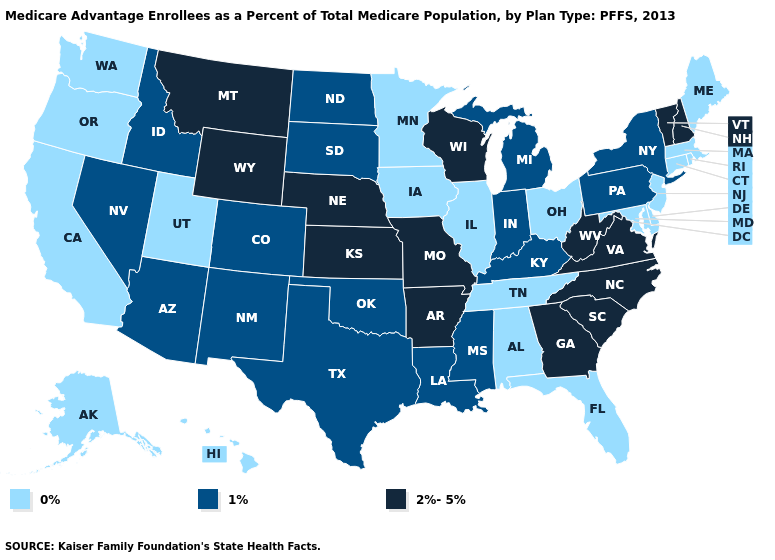Does California have the lowest value in the USA?
Concise answer only. Yes. Does the first symbol in the legend represent the smallest category?
Short answer required. Yes. Name the states that have a value in the range 2%-5%?
Write a very short answer. Arkansas, Georgia, Kansas, Missouri, Montana, North Carolina, Nebraska, New Hampshire, South Carolina, Virginia, Vermont, Wisconsin, West Virginia, Wyoming. What is the value of Mississippi?
Keep it brief. 1%. Name the states that have a value in the range 1%?
Write a very short answer. Arizona, Colorado, Idaho, Indiana, Kentucky, Louisiana, Michigan, Mississippi, North Dakota, New Mexico, Nevada, New York, Oklahoma, Pennsylvania, South Dakota, Texas. What is the value of Tennessee?
Concise answer only. 0%. Name the states that have a value in the range 2%-5%?
Write a very short answer. Arkansas, Georgia, Kansas, Missouri, Montana, North Carolina, Nebraska, New Hampshire, South Carolina, Virginia, Vermont, Wisconsin, West Virginia, Wyoming. What is the value of Minnesota?
Answer briefly. 0%. What is the highest value in states that border New York?
Give a very brief answer. 2%-5%. Which states have the lowest value in the West?
Answer briefly. Alaska, California, Hawaii, Oregon, Utah, Washington. Does the map have missing data?
Quick response, please. No. Does Arkansas have the highest value in the South?
Keep it brief. Yes. What is the highest value in the USA?
Give a very brief answer. 2%-5%. What is the value of Colorado?
Quick response, please. 1%. What is the highest value in the MidWest ?
Concise answer only. 2%-5%. 